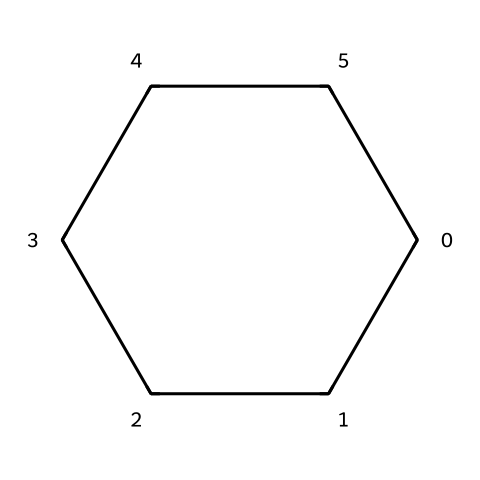What is the molecular formula of this compound? The compound consists of 6 carbon atoms (C) and 12 hydrogen atoms (H), derived from the structure showing each vertex representing a carbon atom, and considering the general formula for cycloalkanes, which is CnH2n (where n is the number of carbon atoms). Here, n=6, thus C6H12.
Answer: C6H12 How many carbon atoms are in cyclohexane? The chemical structure shows six vertices, each representing a carbon atom, confirming that there are six carbon atoms in total.
Answer: 6 What type of bonding is present in cyclohexane? Cyclohexane contains only single covalent bonds between carbon atoms, as indicated by the simple ring structure without any double or triple bonds.
Answer: single bonds What is the shape of the cyclohexane molecule? The cyclohexane structure forms a closed ring, which can be described as having a planar or chair conformation, but primarily presents as a non-planar hexagonal shape typical for cycloalkanes.
Answer: ring How many hydrogen atoms are attached to each carbon in cyclohexane? In cyclohexane, each carbon atom is bonded to two other carbon atoms and is therefore attached to two hydrogen atoms, which is characteristic of cycloalkanes with the formula CnH2n.
Answer: 2 Is cyclohexane a saturated or unsaturated hydrocarbon? Due to all carbon-carbon bonds being single bonds and the presence of the maximum number of hydrogen atoms, cyclohexane is classified as a saturated hydrocarbon.
Answer: saturated What type of hydrocarbon is cyclohexane categorized as? Cyclohexane, with its closed ring structure composed entirely of carbon and hydrogen, is categorized as a cycloalkane, which is a specific type of cyclic hydrocarbon.
Answer: cycloalkane 